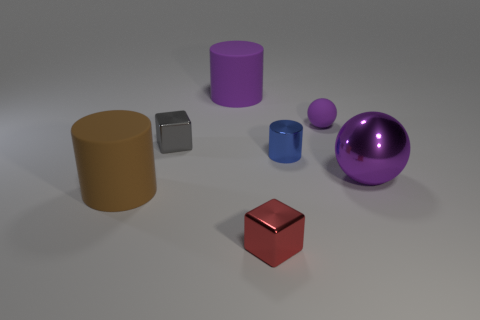Subtract all small blue cylinders. How many cylinders are left? 2 Add 2 red cubes. How many objects exist? 9 Subtract all cubes. How many objects are left? 5 Add 2 purple rubber cylinders. How many purple rubber cylinders are left? 3 Add 2 small blue blocks. How many small blue blocks exist? 2 Subtract 0 cyan cylinders. How many objects are left? 7 Subtract all tiny red things. Subtract all yellow objects. How many objects are left? 6 